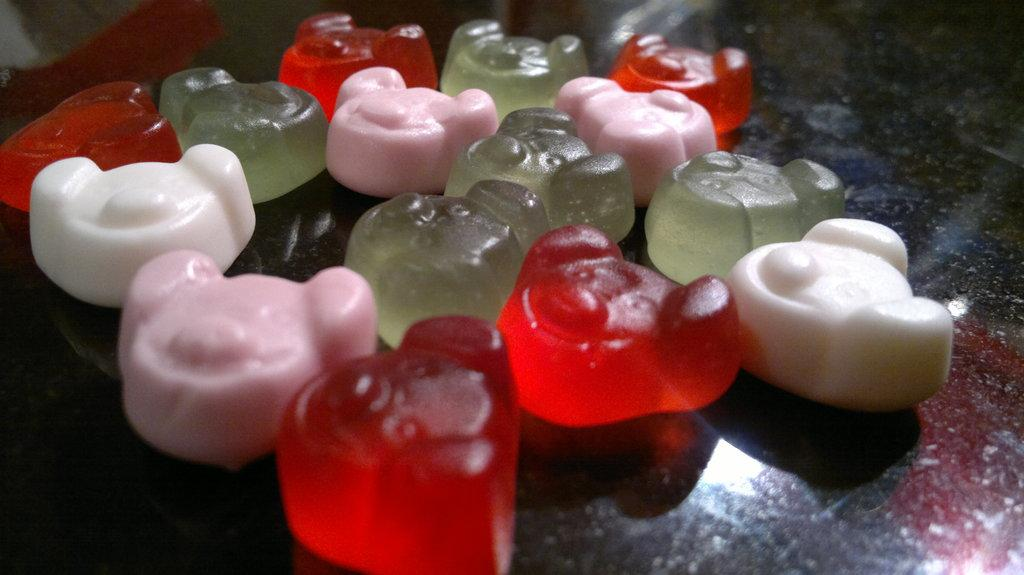What type of food is depicted in the image? There is a gelatin of different colors in the image. Are there any other objects present in the image besides the gelatin? Yes, there are other objects in the image. What is the name of the flower on the left side of the image? There is no flower present in the image. How many eggs are visible in the image? There are no eggs visible in the image. 